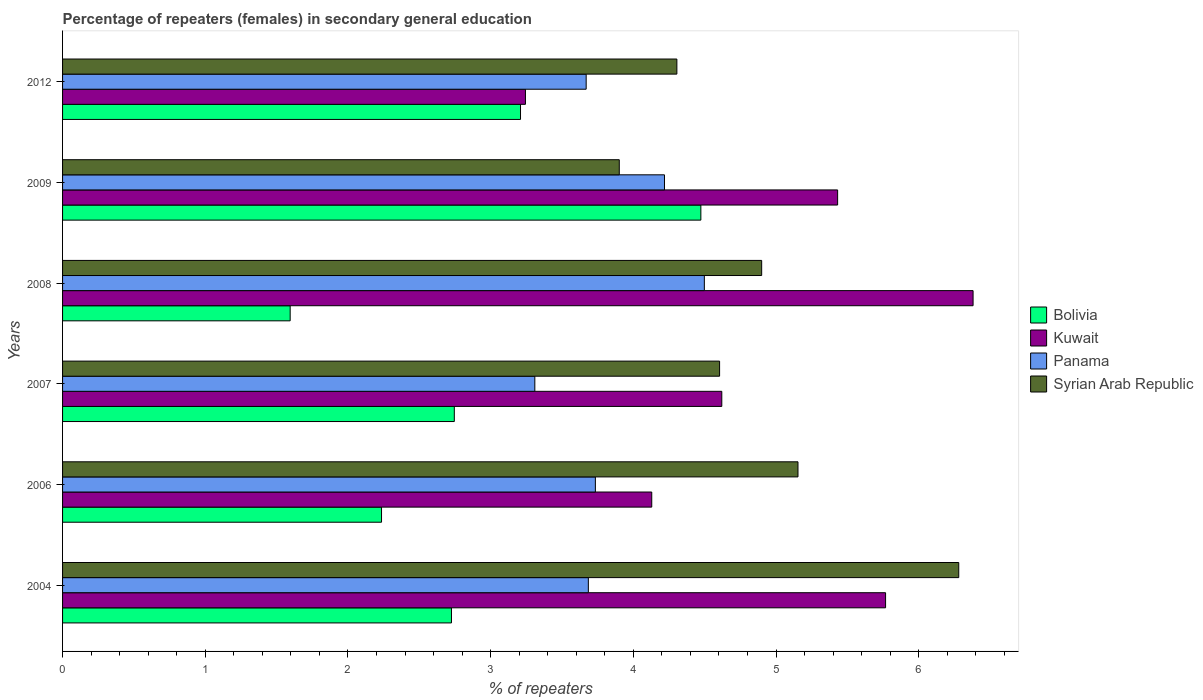How many different coloured bars are there?
Give a very brief answer. 4. How many groups of bars are there?
Your answer should be very brief. 6. How many bars are there on the 5th tick from the bottom?
Ensure brevity in your answer.  4. What is the percentage of female repeaters in Bolivia in 2004?
Provide a succinct answer. 2.73. Across all years, what is the maximum percentage of female repeaters in Syrian Arab Republic?
Give a very brief answer. 6.28. Across all years, what is the minimum percentage of female repeaters in Syrian Arab Republic?
Offer a terse response. 3.9. In which year was the percentage of female repeaters in Panama minimum?
Provide a succinct answer. 2007. What is the total percentage of female repeaters in Bolivia in the graph?
Ensure brevity in your answer.  16.98. What is the difference between the percentage of female repeaters in Bolivia in 2004 and that in 2006?
Keep it short and to the point. 0.49. What is the difference between the percentage of female repeaters in Syrian Arab Republic in 2004 and the percentage of female repeaters in Panama in 2012?
Offer a very short reply. 2.61. What is the average percentage of female repeaters in Kuwait per year?
Make the answer very short. 4.93. In the year 2007, what is the difference between the percentage of female repeaters in Kuwait and percentage of female repeaters in Syrian Arab Republic?
Your answer should be compact. 0.02. What is the ratio of the percentage of female repeaters in Panama in 2009 to that in 2012?
Offer a terse response. 1.15. Is the percentage of female repeaters in Syrian Arab Republic in 2007 less than that in 2008?
Make the answer very short. Yes. Is the difference between the percentage of female repeaters in Kuwait in 2004 and 2008 greater than the difference between the percentage of female repeaters in Syrian Arab Republic in 2004 and 2008?
Your answer should be compact. No. What is the difference between the highest and the second highest percentage of female repeaters in Syrian Arab Republic?
Offer a terse response. 1.13. What is the difference between the highest and the lowest percentage of female repeaters in Panama?
Provide a succinct answer. 1.19. Is the sum of the percentage of female repeaters in Kuwait in 2006 and 2007 greater than the maximum percentage of female repeaters in Panama across all years?
Provide a short and direct response. Yes. Is it the case that in every year, the sum of the percentage of female repeaters in Syrian Arab Republic and percentage of female repeaters in Bolivia is greater than the sum of percentage of female repeaters in Panama and percentage of female repeaters in Kuwait?
Your answer should be compact. No. What does the 2nd bar from the bottom in 2008 represents?
Your response must be concise. Kuwait. Is it the case that in every year, the sum of the percentage of female repeaters in Syrian Arab Republic and percentage of female repeaters in Bolivia is greater than the percentage of female repeaters in Kuwait?
Your answer should be very brief. Yes. Are all the bars in the graph horizontal?
Provide a short and direct response. Yes. What is the difference between two consecutive major ticks on the X-axis?
Your answer should be compact. 1. Does the graph contain any zero values?
Offer a very short reply. No. Does the graph contain grids?
Provide a short and direct response. No. How many legend labels are there?
Offer a very short reply. 4. What is the title of the graph?
Make the answer very short. Percentage of repeaters (females) in secondary general education. Does "Armenia" appear as one of the legend labels in the graph?
Your answer should be very brief. No. What is the label or title of the X-axis?
Make the answer very short. % of repeaters. What is the label or title of the Y-axis?
Your answer should be very brief. Years. What is the % of repeaters in Bolivia in 2004?
Offer a terse response. 2.73. What is the % of repeaters of Kuwait in 2004?
Offer a very short reply. 5.77. What is the % of repeaters of Panama in 2004?
Your answer should be compact. 3.68. What is the % of repeaters of Syrian Arab Republic in 2004?
Keep it short and to the point. 6.28. What is the % of repeaters in Bolivia in 2006?
Your answer should be compact. 2.24. What is the % of repeaters in Kuwait in 2006?
Ensure brevity in your answer.  4.13. What is the % of repeaters in Panama in 2006?
Your answer should be very brief. 3.73. What is the % of repeaters in Syrian Arab Republic in 2006?
Offer a terse response. 5.15. What is the % of repeaters of Bolivia in 2007?
Your answer should be compact. 2.75. What is the % of repeaters in Kuwait in 2007?
Your answer should be compact. 4.62. What is the % of repeaters of Panama in 2007?
Provide a short and direct response. 3.31. What is the % of repeaters of Syrian Arab Republic in 2007?
Keep it short and to the point. 4.6. What is the % of repeaters of Bolivia in 2008?
Offer a very short reply. 1.6. What is the % of repeaters in Kuwait in 2008?
Offer a very short reply. 6.38. What is the % of repeaters of Panama in 2008?
Your answer should be compact. 4.5. What is the % of repeaters of Syrian Arab Republic in 2008?
Make the answer very short. 4.9. What is the % of repeaters of Bolivia in 2009?
Provide a short and direct response. 4.47. What is the % of repeaters of Kuwait in 2009?
Provide a succinct answer. 5.43. What is the % of repeaters of Panama in 2009?
Your response must be concise. 4.22. What is the % of repeaters in Syrian Arab Republic in 2009?
Give a very brief answer. 3.9. What is the % of repeaters in Bolivia in 2012?
Your answer should be very brief. 3.21. What is the % of repeaters in Kuwait in 2012?
Keep it short and to the point. 3.24. What is the % of repeaters in Panama in 2012?
Offer a terse response. 3.67. What is the % of repeaters in Syrian Arab Republic in 2012?
Provide a succinct answer. 4.31. Across all years, what is the maximum % of repeaters in Bolivia?
Provide a short and direct response. 4.47. Across all years, what is the maximum % of repeaters in Kuwait?
Your response must be concise. 6.38. Across all years, what is the maximum % of repeaters in Panama?
Provide a short and direct response. 4.5. Across all years, what is the maximum % of repeaters of Syrian Arab Republic?
Keep it short and to the point. 6.28. Across all years, what is the minimum % of repeaters in Bolivia?
Provide a succinct answer. 1.6. Across all years, what is the minimum % of repeaters in Kuwait?
Keep it short and to the point. 3.24. Across all years, what is the minimum % of repeaters in Panama?
Give a very brief answer. 3.31. Across all years, what is the minimum % of repeaters of Syrian Arab Republic?
Keep it short and to the point. 3.9. What is the total % of repeaters in Bolivia in the graph?
Offer a very short reply. 16.98. What is the total % of repeaters of Kuwait in the graph?
Offer a terse response. 29.57. What is the total % of repeaters in Panama in the graph?
Offer a very short reply. 23.11. What is the total % of repeaters in Syrian Arab Republic in the graph?
Give a very brief answer. 29.15. What is the difference between the % of repeaters in Bolivia in 2004 and that in 2006?
Keep it short and to the point. 0.49. What is the difference between the % of repeaters in Kuwait in 2004 and that in 2006?
Make the answer very short. 1.64. What is the difference between the % of repeaters of Panama in 2004 and that in 2006?
Your answer should be compact. -0.05. What is the difference between the % of repeaters in Syrian Arab Republic in 2004 and that in 2006?
Give a very brief answer. 1.13. What is the difference between the % of repeaters of Bolivia in 2004 and that in 2007?
Provide a succinct answer. -0.02. What is the difference between the % of repeaters of Kuwait in 2004 and that in 2007?
Provide a short and direct response. 1.15. What is the difference between the % of repeaters in Panama in 2004 and that in 2007?
Your response must be concise. 0.38. What is the difference between the % of repeaters of Syrian Arab Republic in 2004 and that in 2007?
Offer a terse response. 1.68. What is the difference between the % of repeaters of Bolivia in 2004 and that in 2008?
Your response must be concise. 1.13. What is the difference between the % of repeaters in Kuwait in 2004 and that in 2008?
Offer a terse response. -0.61. What is the difference between the % of repeaters in Panama in 2004 and that in 2008?
Provide a short and direct response. -0.81. What is the difference between the % of repeaters in Syrian Arab Republic in 2004 and that in 2008?
Make the answer very short. 1.38. What is the difference between the % of repeaters of Bolivia in 2004 and that in 2009?
Provide a succinct answer. -1.75. What is the difference between the % of repeaters in Kuwait in 2004 and that in 2009?
Your answer should be very brief. 0.34. What is the difference between the % of repeaters of Panama in 2004 and that in 2009?
Your answer should be very brief. -0.53. What is the difference between the % of repeaters in Syrian Arab Republic in 2004 and that in 2009?
Offer a terse response. 2.38. What is the difference between the % of repeaters in Bolivia in 2004 and that in 2012?
Offer a terse response. -0.48. What is the difference between the % of repeaters of Kuwait in 2004 and that in 2012?
Your response must be concise. 2.52. What is the difference between the % of repeaters of Panama in 2004 and that in 2012?
Offer a terse response. 0.02. What is the difference between the % of repeaters in Syrian Arab Republic in 2004 and that in 2012?
Your response must be concise. 1.98. What is the difference between the % of repeaters of Bolivia in 2006 and that in 2007?
Ensure brevity in your answer.  -0.51. What is the difference between the % of repeaters in Kuwait in 2006 and that in 2007?
Give a very brief answer. -0.49. What is the difference between the % of repeaters of Panama in 2006 and that in 2007?
Make the answer very short. 0.42. What is the difference between the % of repeaters in Syrian Arab Republic in 2006 and that in 2007?
Your answer should be very brief. 0.55. What is the difference between the % of repeaters of Bolivia in 2006 and that in 2008?
Make the answer very short. 0.64. What is the difference between the % of repeaters of Kuwait in 2006 and that in 2008?
Give a very brief answer. -2.25. What is the difference between the % of repeaters in Panama in 2006 and that in 2008?
Provide a succinct answer. -0.76. What is the difference between the % of repeaters in Syrian Arab Republic in 2006 and that in 2008?
Offer a terse response. 0.25. What is the difference between the % of repeaters in Bolivia in 2006 and that in 2009?
Offer a very short reply. -2.24. What is the difference between the % of repeaters in Kuwait in 2006 and that in 2009?
Keep it short and to the point. -1.3. What is the difference between the % of repeaters of Panama in 2006 and that in 2009?
Your response must be concise. -0.48. What is the difference between the % of repeaters in Syrian Arab Republic in 2006 and that in 2009?
Provide a succinct answer. 1.25. What is the difference between the % of repeaters of Bolivia in 2006 and that in 2012?
Make the answer very short. -0.97. What is the difference between the % of repeaters of Kuwait in 2006 and that in 2012?
Ensure brevity in your answer.  0.89. What is the difference between the % of repeaters in Panama in 2006 and that in 2012?
Your response must be concise. 0.06. What is the difference between the % of repeaters of Syrian Arab Republic in 2006 and that in 2012?
Provide a short and direct response. 0.85. What is the difference between the % of repeaters of Bolivia in 2007 and that in 2008?
Your answer should be compact. 1.15. What is the difference between the % of repeaters of Kuwait in 2007 and that in 2008?
Ensure brevity in your answer.  -1.76. What is the difference between the % of repeaters in Panama in 2007 and that in 2008?
Give a very brief answer. -1.19. What is the difference between the % of repeaters in Syrian Arab Republic in 2007 and that in 2008?
Provide a succinct answer. -0.29. What is the difference between the % of repeaters of Bolivia in 2007 and that in 2009?
Provide a succinct answer. -1.73. What is the difference between the % of repeaters in Kuwait in 2007 and that in 2009?
Your answer should be very brief. -0.81. What is the difference between the % of repeaters of Panama in 2007 and that in 2009?
Offer a terse response. -0.91. What is the difference between the % of repeaters of Syrian Arab Republic in 2007 and that in 2009?
Your answer should be compact. 0.7. What is the difference between the % of repeaters in Bolivia in 2007 and that in 2012?
Offer a terse response. -0.46. What is the difference between the % of repeaters of Kuwait in 2007 and that in 2012?
Make the answer very short. 1.38. What is the difference between the % of repeaters in Panama in 2007 and that in 2012?
Offer a very short reply. -0.36. What is the difference between the % of repeaters of Syrian Arab Republic in 2007 and that in 2012?
Offer a terse response. 0.3. What is the difference between the % of repeaters in Bolivia in 2008 and that in 2009?
Your response must be concise. -2.88. What is the difference between the % of repeaters in Kuwait in 2008 and that in 2009?
Provide a succinct answer. 0.95. What is the difference between the % of repeaters of Panama in 2008 and that in 2009?
Your response must be concise. 0.28. What is the difference between the % of repeaters of Syrian Arab Republic in 2008 and that in 2009?
Provide a succinct answer. 1. What is the difference between the % of repeaters in Bolivia in 2008 and that in 2012?
Provide a succinct answer. -1.61. What is the difference between the % of repeaters in Kuwait in 2008 and that in 2012?
Your response must be concise. 3.14. What is the difference between the % of repeaters in Panama in 2008 and that in 2012?
Give a very brief answer. 0.83. What is the difference between the % of repeaters in Syrian Arab Republic in 2008 and that in 2012?
Keep it short and to the point. 0.59. What is the difference between the % of repeaters in Bolivia in 2009 and that in 2012?
Your answer should be very brief. 1.26. What is the difference between the % of repeaters of Kuwait in 2009 and that in 2012?
Provide a succinct answer. 2.19. What is the difference between the % of repeaters in Panama in 2009 and that in 2012?
Provide a short and direct response. 0.55. What is the difference between the % of repeaters in Syrian Arab Republic in 2009 and that in 2012?
Your answer should be compact. -0.4. What is the difference between the % of repeaters of Bolivia in 2004 and the % of repeaters of Kuwait in 2006?
Make the answer very short. -1.4. What is the difference between the % of repeaters in Bolivia in 2004 and the % of repeaters in Panama in 2006?
Give a very brief answer. -1.01. What is the difference between the % of repeaters of Bolivia in 2004 and the % of repeaters of Syrian Arab Republic in 2006?
Your response must be concise. -2.43. What is the difference between the % of repeaters in Kuwait in 2004 and the % of repeaters in Panama in 2006?
Keep it short and to the point. 2.03. What is the difference between the % of repeaters of Kuwait in 2004 and the % of repeaters of Syrian Arab Republic in 2006?
Offer a terse response. 0.61. What is the difference between the % of repeaters of Panama in 2004 and the % of repeaters of Syrian Arab Republic in 2006?
Provide a succinct answer. -1.47. What is the difference between the % of repeaters of Bolivia in 2004 and the % of repeaters of Kuwait in 2007?
Provide a short and direct response. -1.89. What is the difference between the % of repeaters of Bolivia in 2004 and the % of repeaters of Panama in 2007?
Give a very brief answer. -0.58. What is the difference between the % of repeaters of Bolivia in 2004 and the % of repeaters of Syrian Arab Republic in 2007?
Make the answer very short. -1.88. What is the difference between the % of repeaters in Kuwait in 2004 and the % of repeaters in Panama in 2007?
Make the answer very short. 2.46. What is the difference between the % of repeaters of Kuwait in 2004 and the % of repeaters of Syrian Arab Republic in 2007?
Your answer should be very brief. 1.16. What is the difference between the % of repeaters of Panama in 2004 and the % of repeaters of Syrian Arab Republic in 2007?
Make the answer very short. -0.92. What is the difference between the % of repeaters of Bolivia in 2004 and the % of repeaters of Kuwait in 2008?
Offer a terse response. -3.66. What is the difference between the % of repeaters in Bolivia in 2004 and the % of repeaters in Panama in 2008?
Ensure brevity in your answer.  -1.77. What is the difference between the % of repeaters in Bolivia in 2004 and the % of repeaters in Syrian Arab Republic in 2008?
Offer a very short reply. -2.17. What is the difference between the % of repeaters in Kuwait in 2004 and the % of repeaters in Panama in 2008?
Offer a terse response. 1.27. What is the difference between the % of repeaters of Kuwait in 2004 and the % of repeaters of Syrian Arab Republic in 2008?
Make the answer very short. 0.87. What is the difference between the % of repeaters of Panama in 2004 and the % of repeaters of Syrian Arab Republic in 2008?
Make the answer very short. -1.21. What is the difference between the % of repeaters in Bolivia in 2004 and the % of repeaters in Kuwait in 2009?
Make the answer very short. -2.71. What is the difference between the % of repeaters of Bolivia in 2004 and the % of repeaters of Panama in 2009?
Provide a short and direct response. -1.49. What is the difference between the % of repeaters of Bolivia in 2004 and the % of repeaters of Syrian Arab Republic in 2009?
Make the answer very short. -1.18. What is the difference between the % of repeaters of Kuwait in 2004 and the % of repeaters of Panama in 2009?
Your answer should be very brief. 1.55. What is the difference between the % of repeaters of Kuwait in 2004 and the % of repeaters of Syrian Arab Republic in 2009?
Provide a short and direct response. 1.87. What is the difference between the % of repeaters in Panama in 2004 and the % of repeaters in Syrian Arab Republic in 2009?
Provide a succinct answer. -0.22. What is the difference between the % of repeaters in Bolivia in 2004 and the % of repeaters in Kuwait in 2012?
Your answer should be compact. -0.52. What is the difference between the % of repeaters of Bolivia in 2004 and the % of repeaters of Panama in 2012?
Give a very brief answer. -0.94. What is the difference between the % of repeaters in Bolivia in 2004 and the % of repeaters in Syrian Arab Republic in 2012?
Give a very brief answer. -1.58. What is the difference between the % of repeaters of Kuwait in 2004 and the % of repeaters of Panama in 2012?
Your response must be concise. 2.1. What is the difference between the % of repeaters in Kuwait in 2004 and the % of repeaters in Syrian Arab Republic in 2012?
Ensure brevity in your answer.  1.46. What is the difference between the % of repeaters in Panama in 2004 and the % of repeaters in Syrian Arab Republic in 2012?
Provide a succinct answer. -0.62. What is the difference between the % of repeaters of Bolivia in 2006 and the % of repeaters of Kuwait in 2007?
Offer a terse response. -2.38. What is the difference between the % of repeaters of Bolivia in 2006 and the % of repeaters of Panama in 2007?
Ensure brevity in your answer.  -1.07. What is the difference between the % of repeaters of Bolivia in 2006 and the % of repeaters of Syrian Arab Republic in 2007?
Ensure brevity in your answer.  -2.37. What is the difference between the % of repeaters of Kuwait in 2006 and the % of repeaters of Panama in 2007?
Give a very brief answer. 0.82. What is the difference between the % of repeaters of Kuwait in 2006 and the % of repeaters of Syrian Arab Republic in 2007?
Your answer should be compact. -0.48. What is the difference between the % of repeaters of Panama in 2006 and the % of repeaters of Syrian Arab Republic in 2007?
Offer a terse response. -0.87. What is the difference between the % of repeaters in Bolivia in 2006 and the % of repeaters in Kuwait in 2008?
Provide a succinct answer. -4.15. What is the difference between the % of repeaters in Bolivia in 2006 and the % of repeaters in Panama in 2008?
Your response must be concise. -2.26. What is the difference between the % of repeaters of Bolivia in 2006 and the % of repeaters of Syrian Arab Republic in 2008?
Your answer should be compact. -2.66. What is the difference between the % of repeaters in Kuwait in 2006 and the % of repeaters in Panama in 2008?
Provide a succinct answer. -0.37. What is the difference between the % of repeaters of Kuwait in 2006 and the % of repeaters of Syrian Arab Republic in 2008?
Offer a very short reply. -0.77. What is the difference between the % of repeaters in Panama in 2006 and the % of repeaters in Syrian Arab Republic in 2008?
Ensure brevity in your answer.  -1.17. What is the difference between the % of repeaters of Bolivia in 2006 and the % of repeaters of Kuwait in 2009?
Your response must be concise. -3.2. What is the difference between the % of repeaters of Bolivia in 2006 and the % of repeaters of Panama in 2009?
Your answer should be compact. -1.98. What is the difference between the % of repeaters of Bolivia in 2006 and the % of repeaters of Syrian Arab Republic in 2009?
Provide a succinct answer. -1.67. What is the difference between the % of repeaters in Kuwait in 2006 and the % of repeaters in Panama in 2009?
Provide a short and direct response. -0.09. What is the difference between the % of repeaters in Kuwait in 2006 and the % of repeaters in Syrian Arab Republic in 2009?
Your answer should be very brief. 0.23. What is the difference between the % of repeaters in Panama in 2006 and the % of repeaters in Syrian Arab Republic in 2009?
Keep it short and to the point. -0.17. What is the difference between the % of repeaters in Bolivia in 2006 and the % of repeaters in Kuwait in 2012?
Provide a succinct answer. -1.01. What is the difference between the % of repeaters in Bolivia in 2006 and the % of repeaters in Panama in 2012?
Your answer should be compact. -1.43. What is the difference between the % of repeaters of Bolivia in 2006 and the % of repeaters of Syrian Arab Republic in 2012?
Offer a terse response. -2.07. What is the difference between the % of repeaters in Kuwait in 2006 and the % of repeaters in Panama in 2012?
Keep it short and to the point. 0.46. What is the difference between the % of repeaters of Kuwait in 2006 and the % of repeaters of Syrian Arab Republic in 2012?
Provide a succinct answer. -0.18. What is the difference between the % of repeaters in Panama in 2006 and the % of repeaters in Syrian Arab Republic in 2012?
Your answer should be compact. -0.57. What is the difference between the % of repeaters in Bolivia in 2007 and the % of repeaters in Kuwait in 2008?
Keep it short and to the point. -3.64. What is the difference between the % of repeaters in Bolivia in 2007 and the % of repeaters in Panama in 2008?
Keep it short and to the point. -1.75. What is the difference between the % of repeaters in Bolivia in 2007 and the % of repeaters in Syrian Arab Republic in 2008?
Your answer should be very brief. -2.15. What is the difference between the % of repeaters of Kuwait in 2007 and the % of repeaters of Panama in 2008?
Your response must be concise. 0.12. What is the difference between the % of repeaters in Kuwait in 2007 and the % of repeaters in Syrian Arab Republic in 2008?
Give a very brief answer. -0.28. What is the difference between the % of repeaters of Panama in 2007 and the % of repeaters of Syrian Arab Republic in 2008?
Offer a very short reply. -1.59. What is the difference between the % of repeaters in Bolivia in 2007 and the % of repeaters in Kuwait in 2009?
Keep it short and to the point. -2.69. What is the difference between the % of repeaters in Bolivia in 2007 and the % of repeaters in Panama in 2009?
Offer a very short reply. -1.47. What is the difference between the % of repeaters in Bolivia in 2007 and the % of repeaters in Syrian Arab Republic in 2009?
Offer a very short reply. -1.16. What is the difference between the % of repeaters in Kuwait in 2007 and the % of repeaters in Panama in 2009?
Your response must be concise. 0.4. What is the difference between the % of repeaters of Kuwait in 2007 and the % of repeaters of Syrian Arab Republic in 2009?
Make the answer very short. 0.72. What is the difference between the % of repeaters in Panama in 2007 and the % of repeaters in Syrian Arab Republic in 2009?
Keep it short and to the point. -0.59. What is the difference between the % of repeaters of Bolivia in 2007 and the % of repeaters of Kuwait in 2012?
Your answer should be compact. -0.5. What is the difference between the % of repeaters in Bolivia in 2007 and the % of repeaters in Panama in 2012?
Your answer should be compact. -0.92. What is the difference between the % of repeaters in Bolivia in 2007 and the % of repeaters in Syrian Arab Republic in 2012?
Offer a very short reply. -1.56. What is the difference between the % of repeaters of Kuwait in 2007 and the % of repeaters of Panama in 2012?
Your answer should be compact. 0.95. What is the difference between the % of repeaters of Kuwait in 2007 and the % of repeaters of Syrian Arab Republic in 2012?
Ensure brevity in your answer.  0.31. What is the difference between the % of repeaters in Panama in 2007 and the % of repeaters in Syrian Arab Republic in 2012?
Your answer should be very brief. -1. What is the difference between the % of repeaters in Bolivia in 2008 and the % of repeaters in Kuwait in 2009?
Give a very brief answer. -3.84. What is the difference between the % of repeaters in Bolivia in 2008 and the % of repeaters in Panama in 2009?
Your response must be concise. -2.62. What is the difference between the % of repeaters of Bolivia in 2008 and the % of repeaters of Syrian Arab Republic in 2009?
Your answer should be compact. -2.31. What is the difference between the % of repeaters in Kuwait in 2008 and the % of repeaters in Panama in 2009?
Your answer should be very brief. 2.16. What is the difference between the % of repeaters of Kuwait in 2008 and the % of repeaters of Syrian Arab Republic in 2009?
Provide a short and direct response. 2.48. What is the difference between the % of repeaters of Panama in 2008 and the % of repeaters of Syrian Arab Republic in 2009?
Make the answer very short. 0.6. What is the difference between the % of repeaters of Bolivia in 2008 and the % of repeaters of Kuwait in 2012?
Offer a terse response. -1.65. What is the difference between the % of repeaters of Bolivia in 2008 and the % of repeaters of Panama in 2012?
Your response must be concise. -2.07. What is the difference between the % of repeaters in Bolivia in 2008 and the % of repeaters in Syrian Arab Republic in 2012?
Your response must be concise. -2.71. What is the difference between the % of repeaters of Kuwait in 2008 and the % of repeaters of Panama in 2012?
Make the answer very short. 2.71. What is the difference between the % of repeaters in Kuwait in 2008 and the % of repeaters in Syrian Arab Republic in 2012?
Your response must be concise. 2.08. What is the difference between the % of repeaters in Panama in 2008 and the % of repeaters in Syrian Arab Republic in 2012?
Your answer should be compact. 0.19. What is the difference between the % of repeaters in Bolivia in 2009 and the % of repeaters in Kuwait in 2012?
Offer a very short reply. 1.23. What is the difference between the % of repeaters of Bolivia in 2009 and the % of repeaters of Panama in 2012?
Provide a succinct answer. 0.8. What is the difference between the % of repeaters of Bolivia in 2009 and the % of repeaters of Syrian Arab Republic in 2012?
Ensure brevity in your answer.  0.17. What is the difference between the % of repeaters of Kuwait in 2009 and the % of repeaters of Panama in 2012?
Make the answer very short. 1.76. What is the difference between the % of repeaters in Kuwait in 2009 and the % of repeaters in Syrian Arab Republic in 2012?
Ensure brevity in your answer.  1.13. What is the difference between the % of repeaters of Panama in 2009 and the % of repeaters of Syrian Arab Republic in 2012?
Keep it short and to the point. -0.09. What is the average % of repeaters in Bolivia per year?
Your answer should be compact. 2.83. What is the average % of repeaters of Kuwait per year?
Your response must be concise. 4.93. What is the average % of repeaters of Panama per year?
Ensure brevity in your answer.  3.85. What is the average % of repeaters of Syrian Arab Republic per year?
Provide a succinct answer. 4.86. In the year 2004, what is the difference between the % of repeaters in Bolivia and % of repeaters in Kuwait?
Offer a terse response. -3.04. In the year 2004, what is the difference between the % of repeaters in Bolivia and % of repeaters in Panama?
Your answer should be compact. -0.96. In the year 2004, what is the difference between the % of repeaters of Bolivia and % of repeaters of Syrian Arab Republic?
Provide a succinct answer. -3.56. In the year 2004, what is the difference between the % of repeaters in Kuwait and % of repeaters in Panama?
Provide a short and direct response. 2.08. In the year 2004, what is the difference between the % of repeaters in Kuwait and % of repeaters in Syrian Arab Republic?
Your response must be concise. -0.51. In the year 2004, what is the difference between the % of repeaters of Panama and % of repeaters of Syrian Arab Republic?
Make the answer very short. -2.6. In the year 2006, what is the difference between the % of repeaters in Bolivia and % of repeaters in Kuwait?
Ensure brevity in your answer.  -1.89. In the year 2006, what is the difference between the % of repeaters in Bolivia and % of repeaters in Panama?
Your answer should be compact. -1.5. In the year 2006, what is the difference between the % of repeaters of Bolivia and % of repeaters of Syrian Arab Republic?
Offer a terse response. -2.92. In the year 2006, what is the difference between the % of repeaters of Kuwait and % of repeaters of Panama?
Make the answer very short. 0.4. In the year 2006, what is the difference between the % of repeaters in Kuwait and % of repeaters in Syrian Arab Republic?
Ensure brevity in your answer.  -1.02. In the year 2006, what is the difference between the % of repeaters in Panama and % of repeaters in Syrian Arab Republic?
Make the answer very short. -1.42. In the year 2007, what is the difference between the % of repeaters of Bolivia and % of repeaters of Kuwait?
Your answer should be very brief. -1.87. In the year 2007, what is the difference between the % of repeaters in Bolivia and % of repeaters in Panama?
Keep it short and to the point. -0.56. In the year 2007, what is the difference between the % of repeaters in Bolivia and % of repeaters in Syrian Arab Republic?
Your response must be concise. -1.86. In the year 2007, what is the difference between the % of repeaters of Kuwait and % of repeaters of Panama?
Make the answer very short. 1.31. In the year 2007, what is the difference between the % of repeaters in Kuwait and % of repeaters in Syrian Arab Republic?
Your answer should be compact. 0.02. In the year 2007, what is the difference between the % of repeaters of Panama and % of repeaters of Syrian Arab Republic?
Your answer should be compact. -1.29. In the year 2008, what is the difference between the % of repeaters of Bolivia and % of repeaters of Kuwait?
Provide a succinct answer. -4.79. In the year 2008, what is the difference between the % of repeaters of Bolivia and % of repeaters of Panama?
Your answer should be very brief. -2.9. In the year 2008, what is the difference between the % of repeaters of Bolivia and % of repeaters of Syrian Arab Republic?
Provide a short and direct response. -3.3. In the year 2008, what is the difference between the % of repeaters of Kuwait and % of repeaters of Panama?
Give a very brief answer. 1.88. In the year 2008, what is the difference between the % of repeaters in Kuwait and % of repeaters in Syrian Arab Republic?
Provide a short and direct response. 1.48. In the year 2008, what is the difference between the % of repeaters of Panama and % of repeaters of Syrian Arab Republic?
Give a very brief answer. -0.4. In the year 2009, what is the difference between the % of repeaters of Bolivia and % of repeaters of Kuwait?
Provide a succinct answer. -0.96. In the year 2009, what is the difference between the % of repeaters in Bolivia and % of repeaters in Panama?
Provide a succinct answer. 0.25. In the year 2009, what is the difference between the % of repeaters in Bolivia and % of repeaters in Syrian Arab Republic?
Ensure brevity in your answer.  0.57. In the year 2009, what is the difference between the % of repeaters in Kuwait and % of repeaters in Panama?
Offer a terse response. 1.21. In the year 2009, what is the difference between the % of repeaters in Kuwait and % of repeaters in Syrian Arab Republic?
Give a very brief answer. 1.53. In the year 2009, what is the difference between the % of repeaters in Panama and % of repeaters in Syrian Arab Republic?
Your response must be concise. 0.32. In the year 2012, what is the difference between the % of repeaters in Bolivia and % of repeaters in Kuwait?
Keep it short and to the point. -0.03. In the year 2012, what is the difference between the % of repeaters of Bolivia and % of repeaters of Panama?
Provide a short and direct response. -0.46. In the year 2012, what is the difference between the % of repeaters in Bolivia and % of repeaters in Syrian Arab Republic?
Ensure brevity in your answer.  -1.1. In the year 2012, what is the difference between the % of repeaters of Kuwait and % of repeaters of Panama?
Offer a very short reply. -0.43. In the year 2012, what is the difference between the % of repeaters of Kuwait and % of repeaters of Syrian Arab Republic?
Your response must be concise. -1.06. In the year 2012, what is the difference between the % of repeaters of Panama and % of repeaters of Syrian Arab Republic?
Your answer should be very brief. -0.64. What is the ratio of the % of repeaters of Bolivia in 2004 to that in 2006?
Provide a succinct answer. 1.22. What is the ratio of the % of repeaters of Kuwait in 2004 to that in 2006?
Give a very brief answer. 1.4. What is the ratio of the % of repeaters of Syrian Arab Republic in 2004 to that in 2006?
Keep it short and to the point. 1.22. What is the ratio of the % of repeaters in Bolivia in 2004 to that in 2007?
Offer a very short reply. 0.99. What is the ratio of the % of repeaters of Kuwait in 2004 to that in 2007?
Make the answer very short. 1.25. What is the ratio of the % of repeaters of Panama in 2004 to that in 2007?
Give a very brief answer. 1.11. What is the ratio of the % of repeaters in Syrian Arab Republic in 2004 to that in 2007?
Your answer should be compact. 1.36. What is the ratio of the % of repeaters of Bolivia in 2004 to that in 2008?
Make the answer very short. 1.71. What is the ratio of the % of repeaters in Kuwait in 2004 to that in 2008?
Make the answer very short. 0.9. What is the ratio of the % of repeaters in Panama in 2004 to that in 2008?
Offer a very short reply. 0.82. What is the ratio of the % of repeaters of Syrian Arab Republic in 2004 to that in 2008?
Your answer should be very brief. 1.28. What is the ratio of the % of repeaters of Bolivia in 2004 to that in 2009?
Offer a terse response. 0.61. What is the ratio of the % of repeaters of Kuwait in 2004 to that in 2009?
Ensure brevity in your answer.  1.06. What is the ratio of the % of repeaters of Panama in 2004 to that in 2009?
Make the answer very short. 0.87. What is the ratio of the % of repeaters of Syrian Arab Republic in 2004 to that in 2009?
Your answer should be very brief. 1.61. What is the ratio of the % of repeaters in Bolivia in 2004 to that in 2012?
Ensure brevity in your answer.  0.85. What is the ratio of the % of repeaters of Kuwait in 2004 to that in 2012?
Your answer should be compact. 1.78. What is the ratio of the % of repeaters of Syrian Arab Republic in 2004 to that in 2012?
Ensure brevity in your answer.  1.46. What is the ratio of the % of repeaters in Bolivia in 2006 to that in 2007?
Provide a short and direct response. 0.81. What is the ratio of the % of repeaters in Kuwait in 2006 to that in 2007?
Keep it short and to the point. 0.89. What is the ratio of the % of repeaters of Panama in 2006 to that in 2007?
Your answer should be very brief. 1.13. What is the ratio of the % of repeaters of Syrian Arab Republic in 2006 to that in 2007?
Your answer should be very brief. 1.12. What is the ratio of the % of repeaters of Bolivia in 2006 to that in 2008?
Make the answer very short. 1.4. What is the ratio of the % of repeaters in Kuwait in 2006 to that in 2008?
Make the answer very short. 0.65. What is the ratio of the % of repeaters in Panama in 2006 to that in 2008?
Offer a very short reply. 0.83. What is the ratio of the % of repeaters of Syrian Arab Republic in 2006 to that in 2008?
Offer a terse response. 1.05. What is the ratio of the % of repeaters in Bolivia in 2006 to that in 2009?
Offer a very short reply. 0.5. What is the ratio of the % of repeaters of Kuwait in 2006 to that in 2009?
Keep it short and to the point. 0.76. What is the ratio of the % of repeaters of Panama in 2006 to that in 2009?
Offer a very short reply. 0.89. What is the ratio of the % of repeaters in Syrian Arab Republic in 2006 to that in 2009?
Make the answer very short. 1.32. What is the ratio of the % of repeaters of Bolivia in 2006 to that in 2012?
Provide a succinct answer. 0.7. What is the ratio of the % of repeaters in Kuwait in 2006 to that in 2012?
Offer a terse response. 1.27. What is the ratio of the % of repeaters in Panama in 2006 to that in 2012?
Your response must be concise. 1.02. What is the ratio of the % of repeaters in Syrian Arab Republic in 2006 to that in 2012?
Provide a short and direct response. 1.2. What is the ratio of the % of repeaters of Bolivia in 2007 to that in 2008?
Make the answer very short. 1.72. What is the ratio of the % of repeaters in Kuwait in 2007 to that in 2008?
Ensure brevity in your answer.  0.72. What is the ratio of the % of repeaters of Panama in 2007 to that in 2008?
Your answer should be compact. 0.74. What is the ratio of the % of repeaters in Syrian Arab Republic in 2007 to that in 2008?
Offer a very short reply. 0.94. What is the ratio of the % of repeaters in Bolivia in 2007 to that in 2009?
Your answer should be compact. 0.61. What is the ratio of the % of repeaters of Kuwait in 2007 to that in 2009?
Offer a terse response. 0.85. What is the ratio of the % of repeaters of Panama in 2007 to that in 2009?
Provide a short and direct response. 0.78. What is the ratio of the % of repeaters in Syrian Arab Republic in 2007 to that in 2009?
Offer a very short reply. 1.18. What is the ratio of the % of repeaters in Bolivia in 2007 to that in 2012?
Offer a very short reply. 0.86. What is the ratio of the % of repeaters in Kuwait in 2007 to that in 2012?
Offer a terse response. 1.42. What is the ratio of the % of repeaters in Panama in 2007 to that in 2012?
Ensure brevity in your answer.  0.9. What is the ratio of the % of repeaters of Syrian Arab Republic in 2007 to that in 2012?
Ensure brevity in your answer.  1.07. What is the ratio of the % of repeaters in Bolivia in 2008 to that in 2009?
Give a very brief answer. 0.36. What is the ratio of the % of repeaters in Kuwait in 2008 to that in 2009?
Give a very brief answer. 1.17. What is the ratio of the % of repeaters in Panama in 2008 to that in 2009?
Your answer should be compact. 1.07. What is the ratio of the % of repeaters in Syrian Arab Republic in 2008 to that in 2009?
Offer a terse response. 1.26. What is the ratio of the % of repeaters of Bolivia in 2008 to that in 2012?
Your answer should be very brief. 0.5. What is the ratio of the % of repeaters in Kuwait in 2008 to that in 2012?
Offer a terse response. 1.97. What is the ratio of the % of repeaters of Panama in 2008 to that in 2012?
Ensure brevity in your answer.  1.23. What is the ratio of the % of repeaters of Syrian Arab Republic in 2008 to that in 2012?
Offer a very short reply. 1.14. What is the ratio of the % of repeaters of Bolivia in 2009 to that in 2012?
Keep it short and to the point. 1.39. What is the ratio of the % of repeaters of Kuwait in 2009 to that in 2012?
Make the answer very short. 1.67. What is the ratio of the % of repeaters of Panama in 2009 to that in 2012?
Keep it short and to the point. 1.15. What is the ratio of the % of repeaters in Syrian Arab Republic in 2009 to that in 2012?
Offer a very short reply. 0.91. What is the difference between the highest and the second highest % of repeaters in Bolivia?
Make the answer very short. 1.26. What is the difference between the highest and the second highest % of repeaters of Kuwait?
Your answer should be compact. 0.61. What is the difference between the highest and the second highest % of repeaters in Panama?
Make the answer very short. 0.28. What is the difference between the highest and the second highest % of repeaters in Syrian Arab Republic?
Your response must be concise. 1.13. What is the difference between the highest and the lowest % of repeaters of Bolivia?
Keep it short and to the point. 2.88. What is the difference between the highest and the lowest % of repeaters in Kuwait?
Provide a short and direct response. 3.14. What is the difference between the highest and the lowest % of repeaters of Panama?
Offer a terse response. 1.19. What is the difference between the highest and the lowest % of repeaters in Syrian Arab Republic?
Keep it short and to the point. 2.38. 